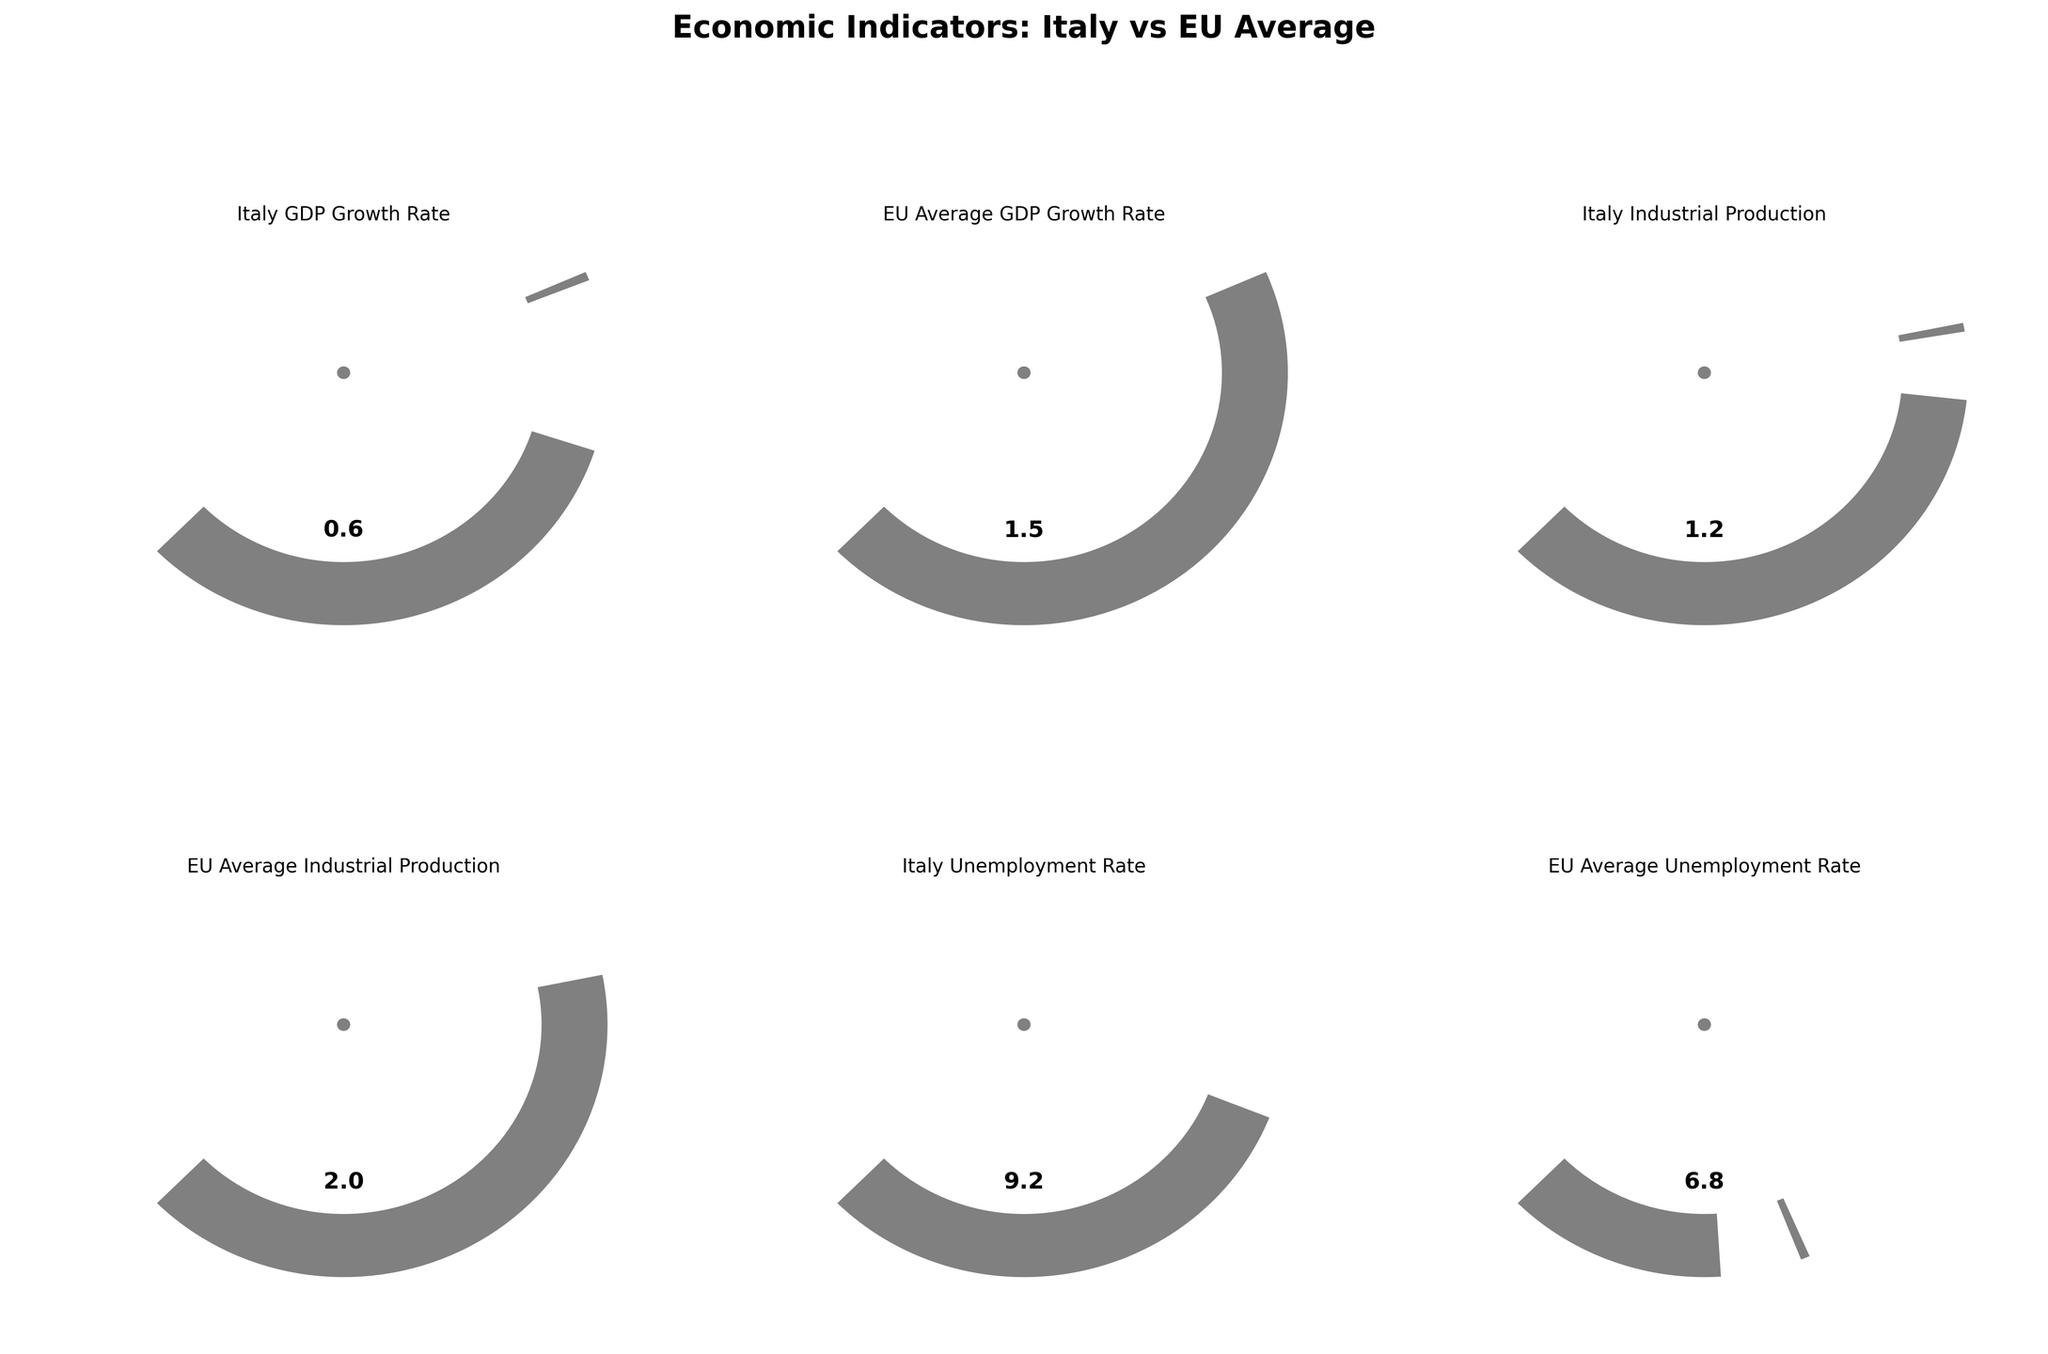What is the value of the Italy GDP Growth Rate? The gauge chart for Italy's GDP Growth Rate shows the value indicated near the top of the gauge.
Answer: 0.6 How does the Italy GDP Growth Rate compare with the EU Average GDP Growth Rate? By comparing the gauge charts, the Italy GDP Growth Rate is at 0.6 whereas the EU Average is at 1.5, thus Italy's rate is lower than the EU average.
Answer: Lower What is the relationship between Italy's and EU's Industrial Production? On the gauge charts, the Italy Industrial Production is at 1.2 while the EU Average Industrial Production is at 2.0, indicating Italy's industrial production is lower than the EU average.
Answer: Lower What is the indicator that deviates most from its average value? By observing the deviation of each indicator's value from its average, the Italy Unemployment Rate (9.2) deviates more from its average (7.5) compared to the other indicators.
Answer: Italy Unemployment Rate Which Italy economic indicator is closest to its maximum value? By looking at each gauge chart, the Italy Industrial Production at 1.2 is the closest to its maximum value (8) compared to the other indicators.
Answer: Italy Industrial Production What is the difference between Italy's Unemployment Rate and the EU Average Unemployment Rate? The gauge charts show that Italy's Unemployment Rate is 9.2, and the EU Average is 6.8. The difference is 9.2 - 6.8 = 2.4.
Answer: 2.4 Which economic indicator has the smallest difference between Italy and the EU average? By observing the gauge charts, the Italy GDP Growth Rate (0.6) and EU GDP Growth Rate (1.5) have the smallest difference compared to other indicators' differences.
Answer: GDP Growth Rate What is the average value used for the Italy Industrial Production gauge chart? The average value is indicated in the data table for Italy Industrial Production, which is 2.0.
Answer: 2.0 